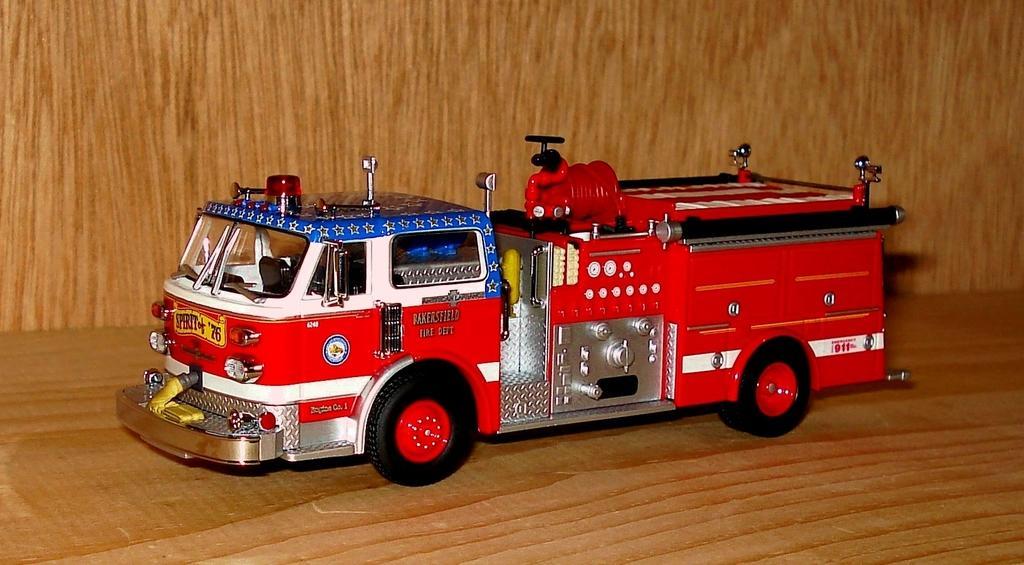How would you summarize this image in a sentence or two? There is a toy of a fire engine on a wooden surface. In the back there is a wooden wall. 